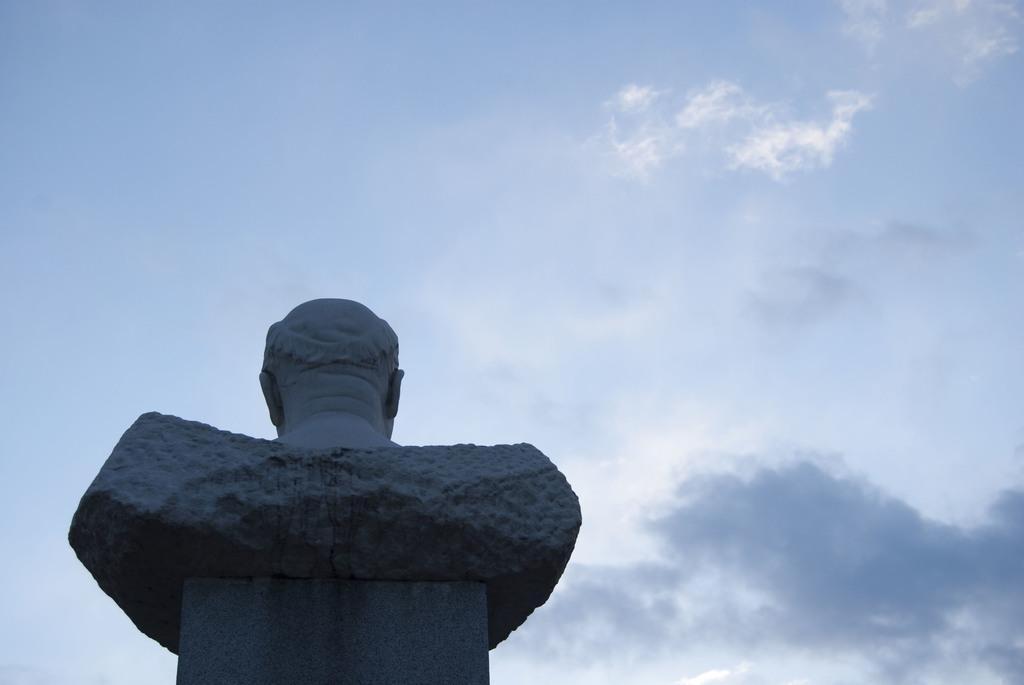What is the main subject in the image? There is a statue in the image. What can be seen in the sky in the image? There are clouds in the sky in the image. What type of jeans is the statue wearing in the image? The statue is not wearing jeans, as it is a statue and not a person. 